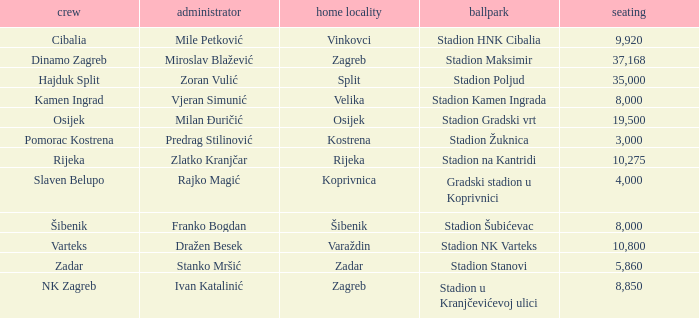What is the stadium of the NK Zagreb? Stadion u Kranjčevićevoj ulici. 